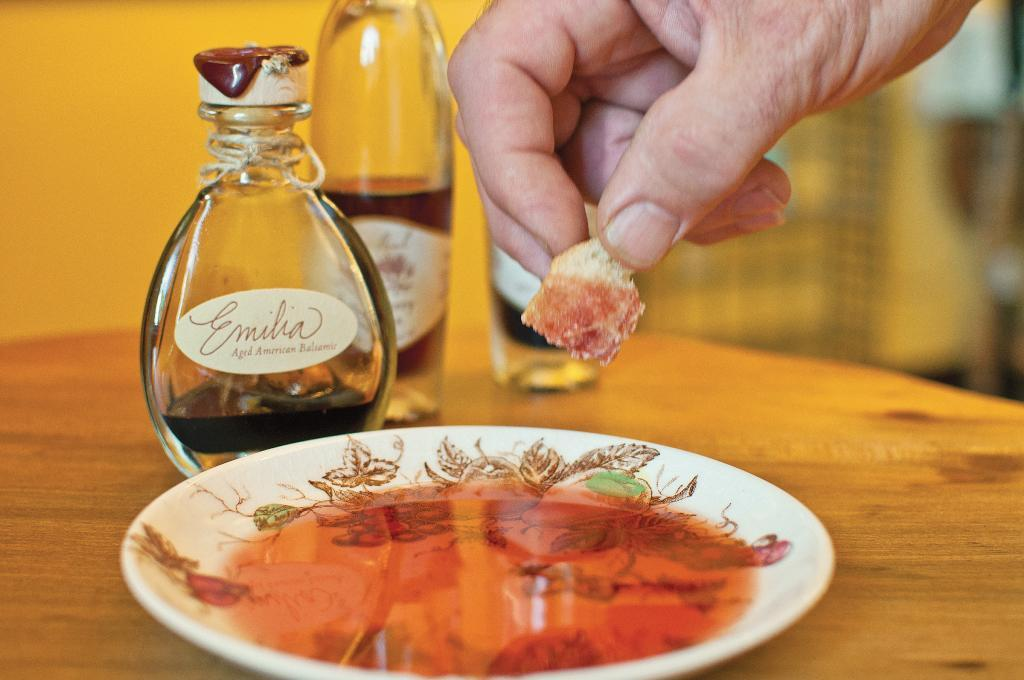What is located in the center of the image? There is a table in the center of the image. What is placed on the table? There is a plate and bottles on the table. Can you describe the human presence in the image? A human hand is visible in the image. What can be seen in the background of the image? There is a wall in the background of the image. What type of bear is sitting on the table in the image? There is no bear present in the image; only a table, plate, bottles, and a human hand are visible. What color is the hair on the person's head in the image? There is no person's head visible in the image, only a human hand is present. 